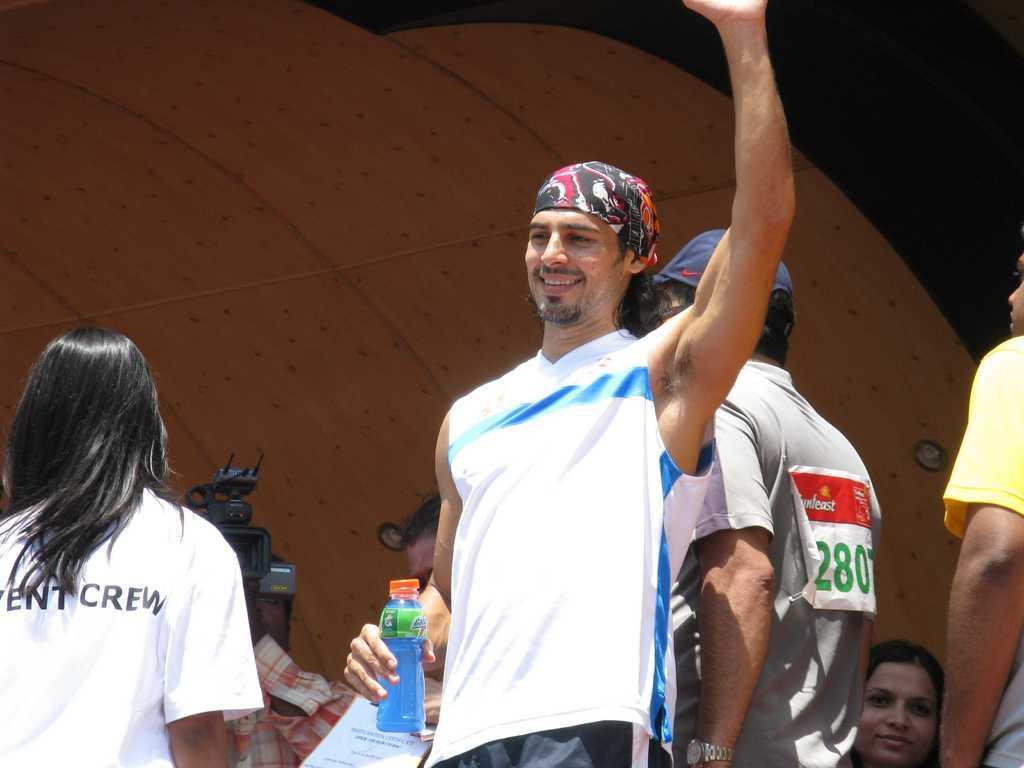Could you give a brief overview of what you see in this image? The persons are standing. In-front this person is holding a bottle. Far there is a camera. 